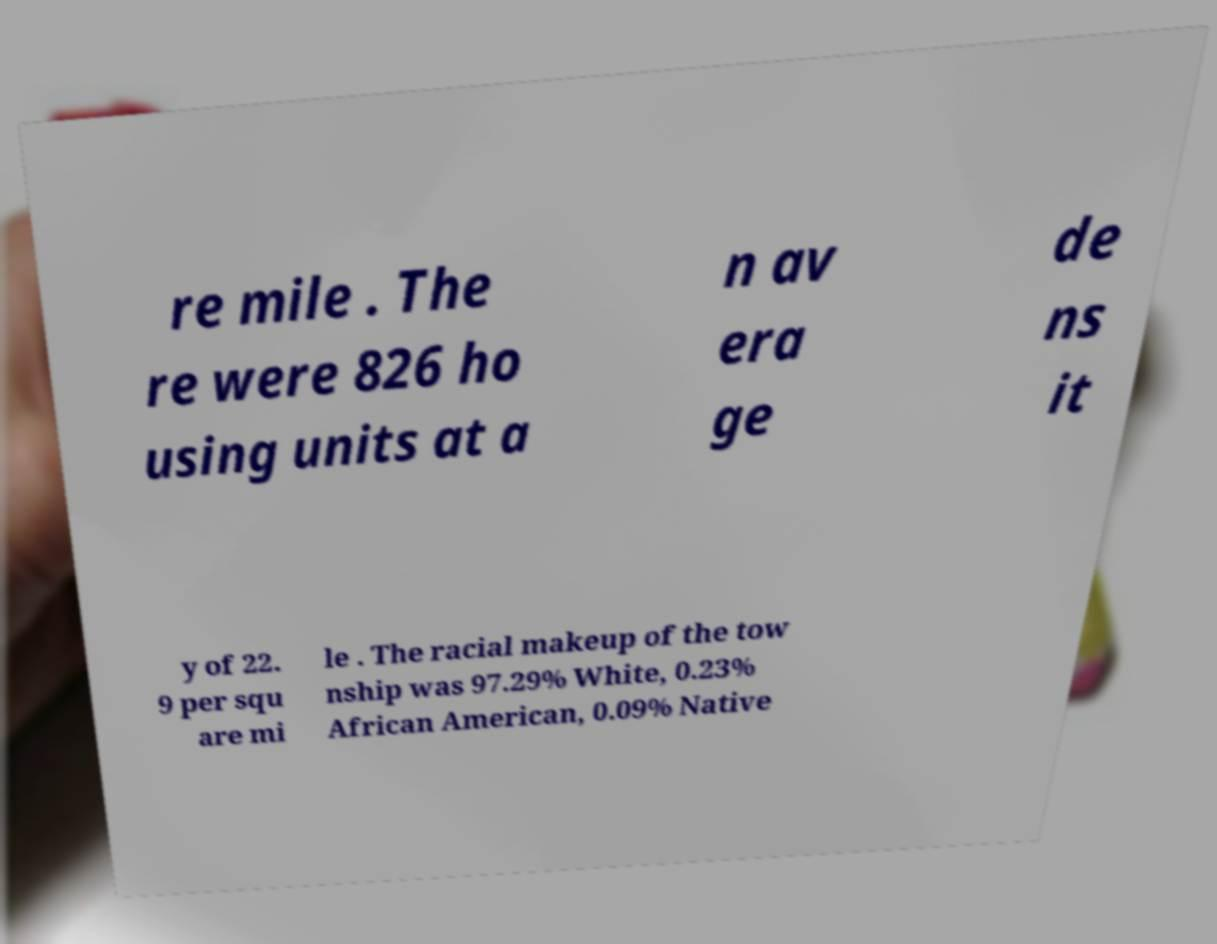Could you extract and type out the text from this image? re mile . The re were 826 ho using units at a n av era ge de ns it y of 22. 9 per squ are mi le . The racial makeup of the tow nship was 97.29% White, 0.23% African American, 0.09% Native 